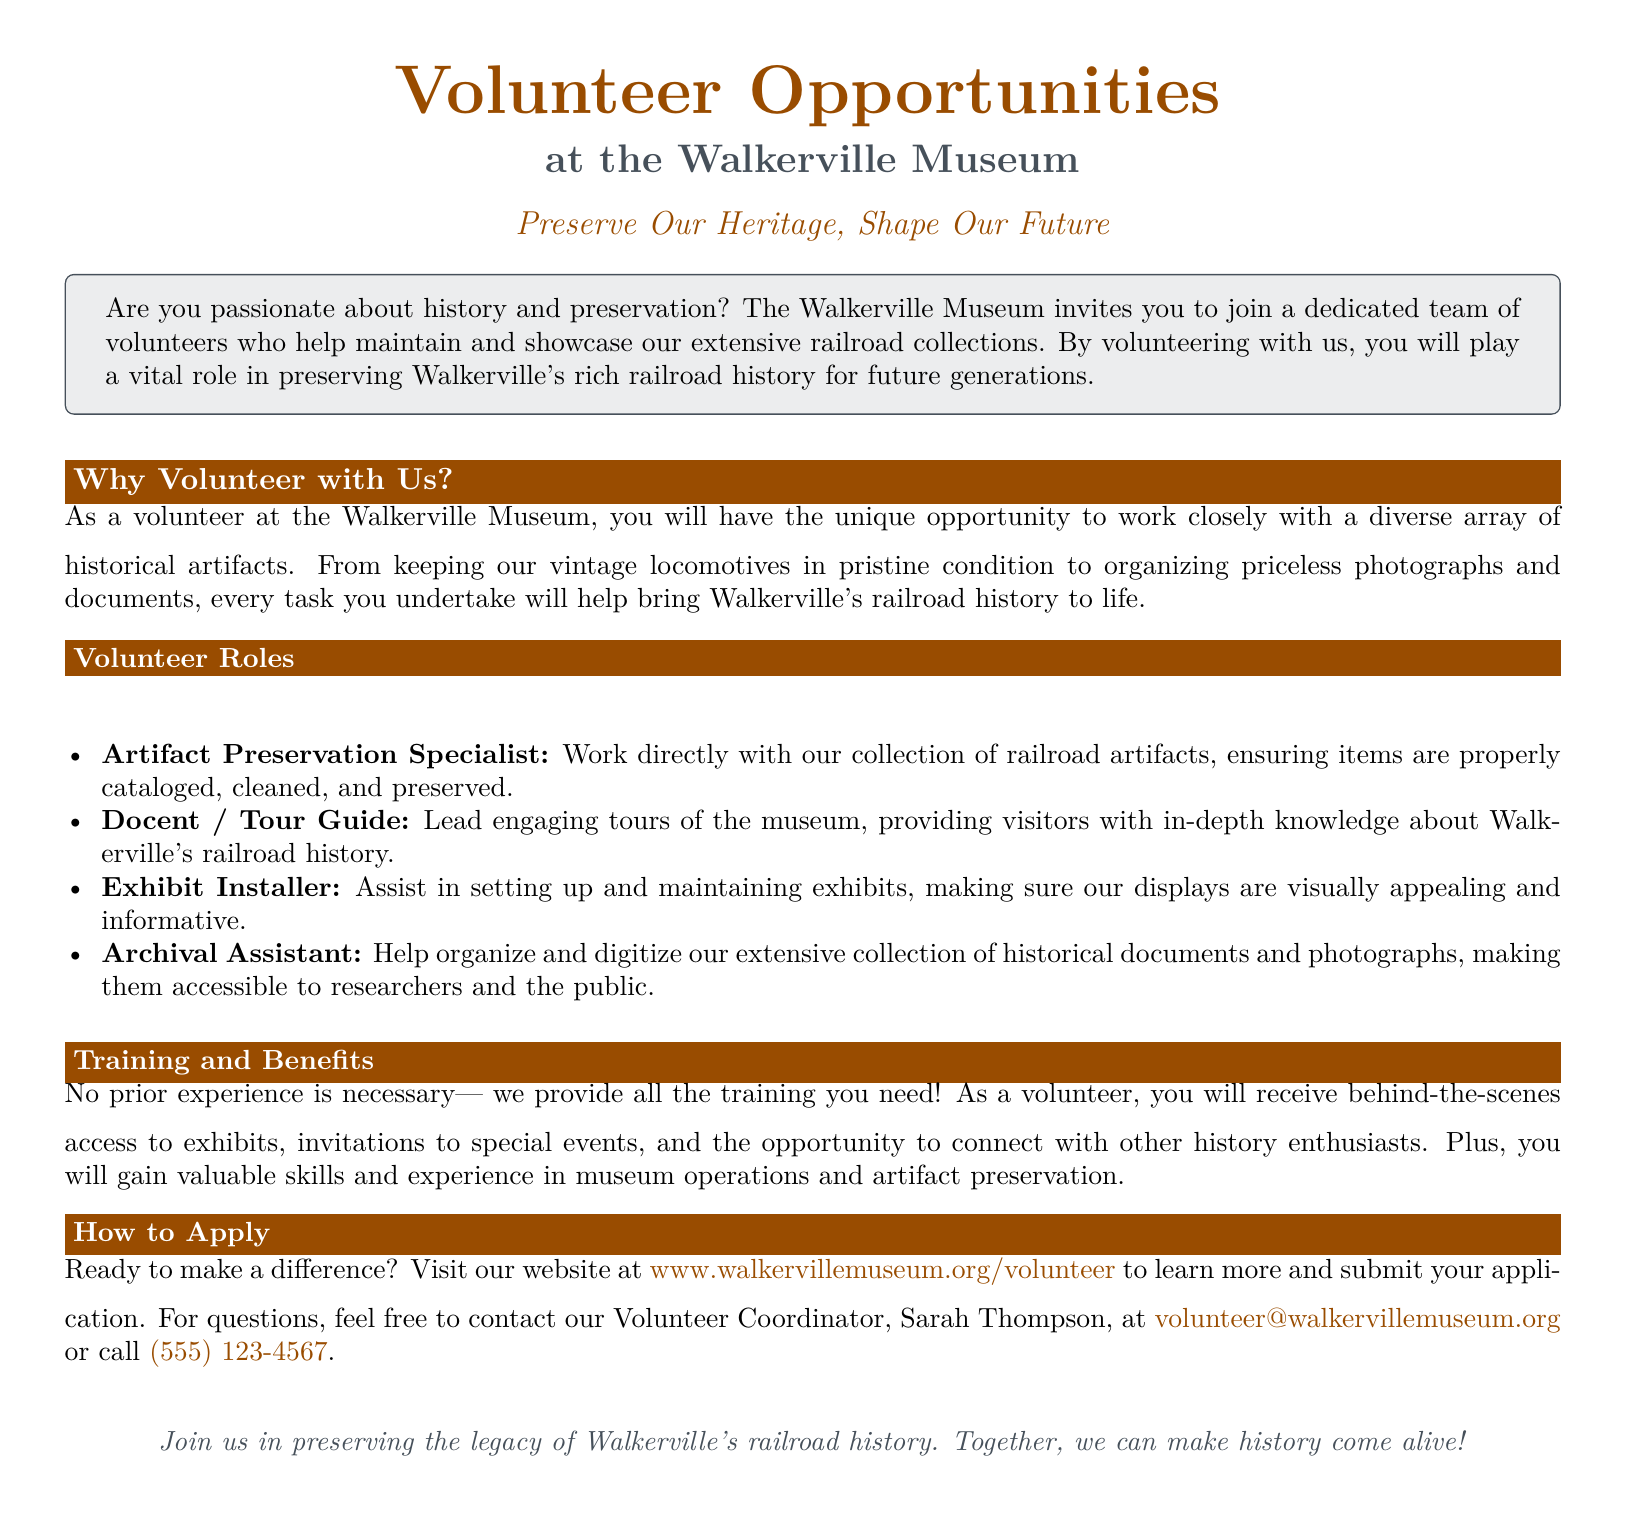What is the main theme of the advertisement? The main theme of the advertisement focuses on encouraging individuals to volunteer for the preservation of Walkerville's railroad history.
Answer: Preserve Our Heritage, Shape Our Future Who is the Volunteer Coordinator? The document specifies the name of the Volunteer Coordinator for contacting inquiries.
Answer: Sarah Thompson What types of volunteer roles are mentioned in the document? The advertisement lists specific roles within the volunteer opportunities provided at the museum.
Answer: Artifact Preservation Specialist, Docent / Tour Guide, Exhibit Installer, Archival Assistant Is prior experience necessary to volunteer? The document addresses the necessity of prior experience for potential volunteers.
Answer: No What benefits do volunteers receive? The advertisement outlines the advantages that come with being a volunteer at the museum.
Answer: Behind-the-scenes access, invitations to special events, valuable skills and experience How can one apply to volunteer? The document provides a specific method for applying to volunteer at the museum.
Answer: Visit www.walkervillemuseum.org/volunteer What is the overall aim of the volunteer program? The advertisement clarifies the purpose behind recruiting volunteers for the museum's programs.
Answer: Preserving Walkerville's rich railroad history for future generations What color is the title "Volunteer Opportunities" written in? The document describes the color used for the title in the advertisement.
Answer: Railroad rust 